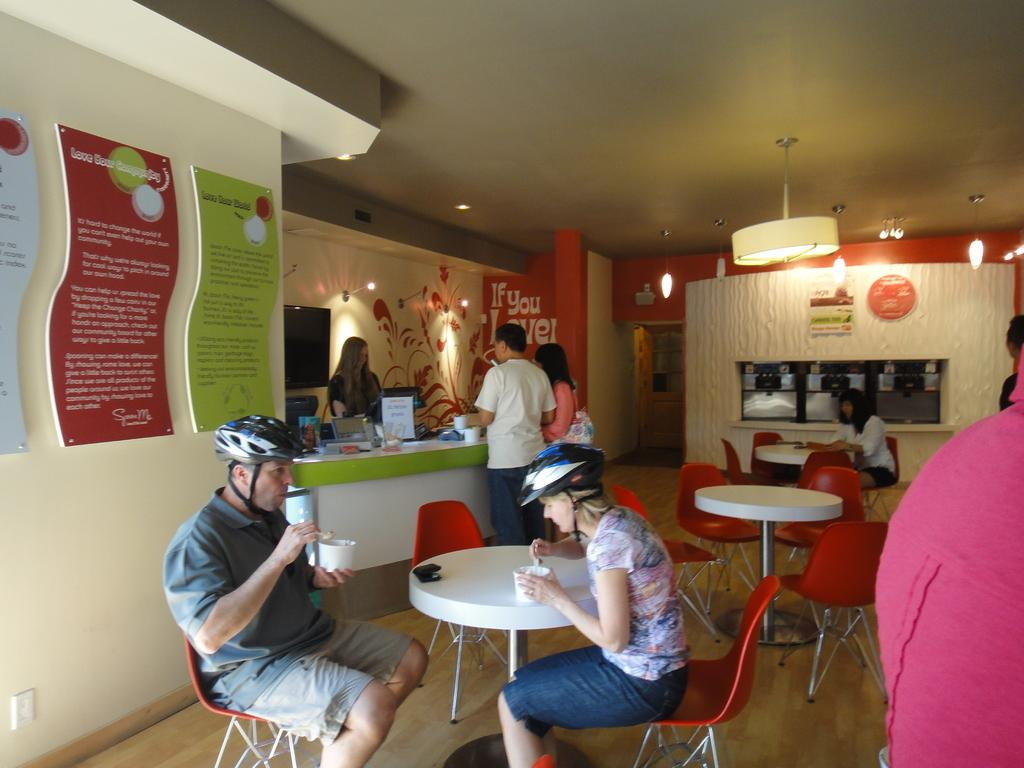What type of establishment is shown in the image? The image depicts a cafeteria. What furniture is present in the cafeteria? There are chairs and tables in the cafeteria. What is the purpose of the cabin in the cafeteria? A lady is standing in the cabin, which suggests it might be a cashier or service area. How are people using the chairs in the cafeteria? There are people sitting on the chairs. How many tickets does the lady in the cabin need to serve the customers? There is no mention of tickets in the image, as it depicts a cafeteria setting. 